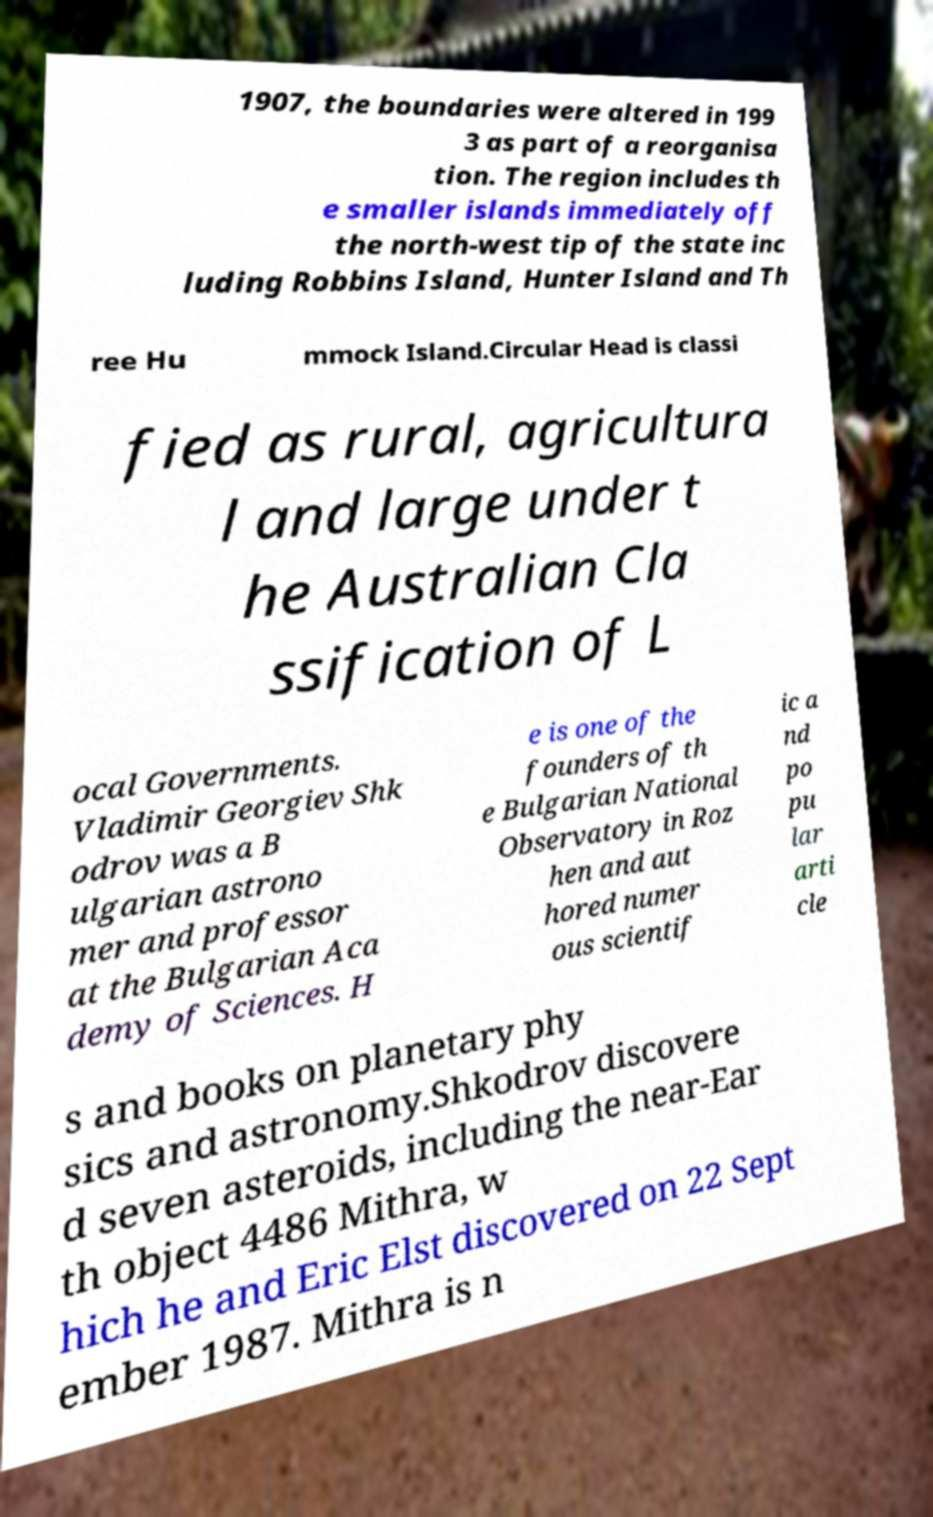Can you accurately transcribe the text from the provided image for me? 1907, the boundaries were altered in 199 3 as part of a reorganisa tion. The region includes th e smaller islands immediately off the north-west tip of the state inc luding Robbins Island, Hunter Island and Th ree Hu mmock Island.Circular Head is classi fied as rural, agricultura l and large under t he Australian Cla ssification of L ocal Governments. Vladimir Georgiev Shk odrov was a B ulgarian astrono mer and professor at the Bulgarian Aca demy of Sciences. H e is one of the founders of th e Bulgarian National Observatory in Roz hen and aut hored numer ous scientif ic a nd po pu lar arti cle s and books on planetary phy sics and astronomy.Shkodrov discovere d seven asteroids, including the near-Ear th object 4486 Mithra, w hich he and Eric Elst discovered on 22 Sept ember 1987. Mithra is n 